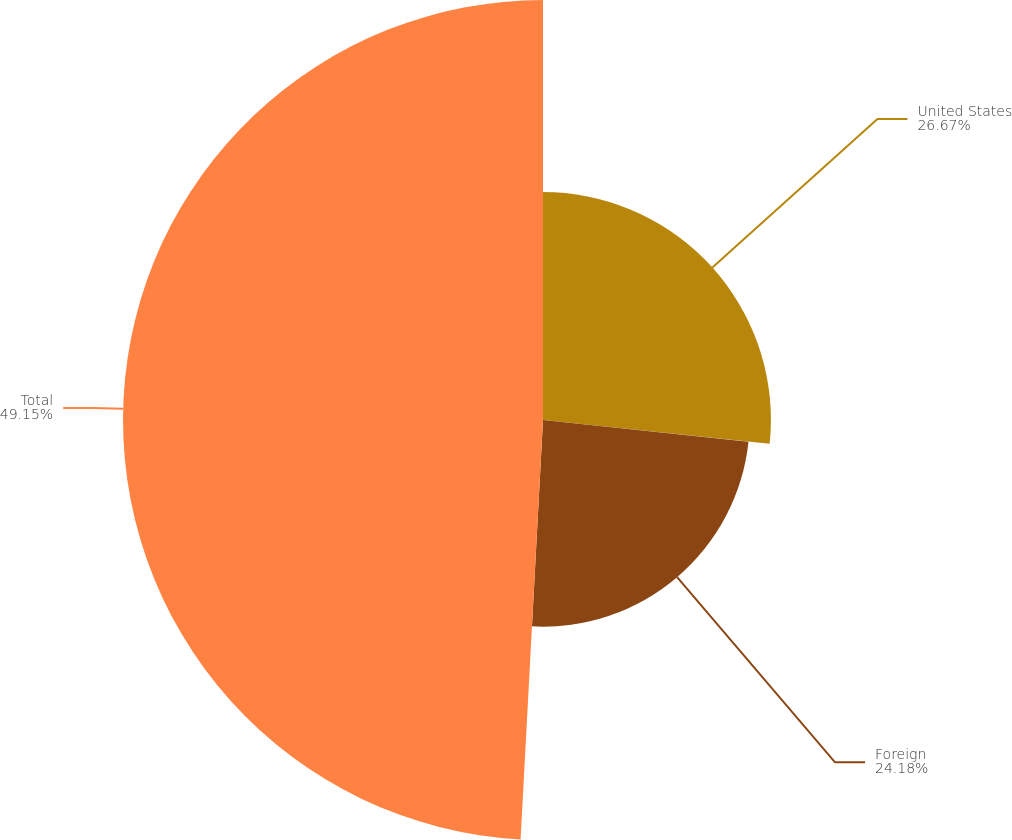Convert chart. <chart><loc_0><loc_0><loc_500><loc_500><pie_chart><fcel>United States<fcel>Foreign<fcel>Total<nl><fcel>26.67%<fcel>24.18%<fcel>49.15%<nl></chart> 